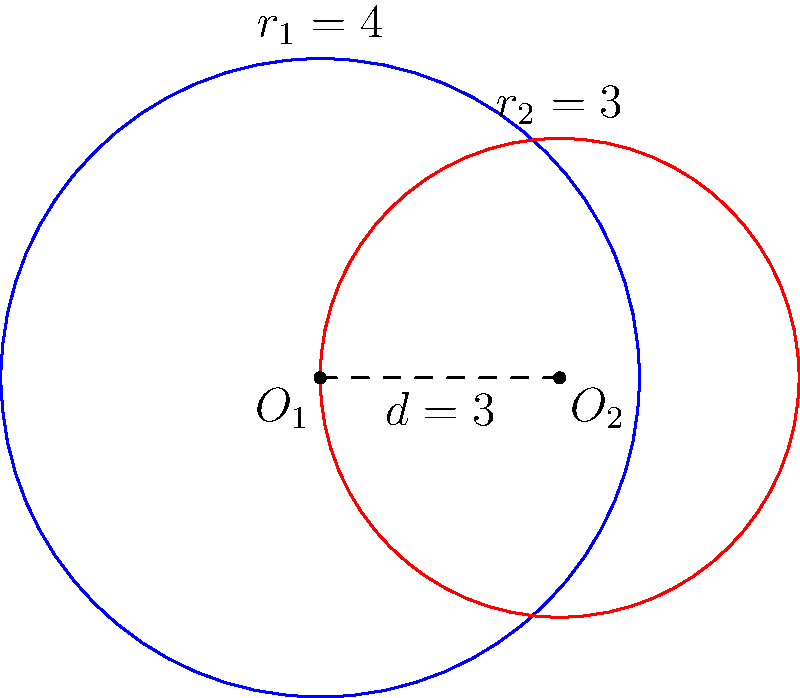In a political corruption network, two influential figures have circular zones of influence. Figure A's zone has a radius of 4 units, while Figure B's zone has a radius of 3 units. The centers of their zones are 3 units apart. Calculate the area of overlap between their zones of influence, representing the region where their corrupt activities intersect. Round your answer to two decimal places. To find the area of overlap between two circles, we'll use the formula for the area of intersection:

$$A = r_1^2 \arccos(\frac{d^2 + r_1^2 - r_2^2}{2dr_1}) + r_2^2 \arccos(\frac{d^2 + r_2^2 - r_1^2}{2dr_2}) - \frac{1}{2}\sqrt{(-d+r_1+r_2)(d+r_1-r_2)(d-r_1+r_2)(d+r_1+r_2)}$$

Where:
$r_1 = 4$ (radius of Figure A's zone)
$r_2 = 3$ (radius of Figure B's zone)
$d = 3$ (distance between centers)

Step 1: Calculate the first term
$$r_1^2 \arccos(\frac{d^2 + r_1^2 - r_2^2}{2dr_1}) = 16 \arccos(\frac{3^2 + 4^2 - 3^2}{2 \cdot 3 \cdot 4}) = 16 \arccos(\frac{13}{24}) \approx 11.7475$$

Step 2: Calculate the second term
$$r_2^2 \arccos(\frac{d^2 + r_2^2 - r_1^2}{2dr_2}) = 9 \arccos(\frac{3^2 + 3^2 - 4^2}{2 \cdot 3 \cdot 3}) = 9 \arccos(\frac{2}{6}) \approx 12.3607$$

Step 3: Calculate the third term
$$\frac{1}{2}\sqrt{(-d+r_1+r_2)(d+r_1-r_2)(d-r_1+r_2)(d+r_1+r_2)} = \frac{1}{2}\sqrt{(4)(4)(0)(10)} = 0$$

Step 4: Sum up the terms
$$A = 11.7475 + 12.3607 - 0 = 24.1082$$

Step 5: Round to two decimal places
$$A \approx 24.11 \text{ square units}$$
Answer: 24.11 square units 